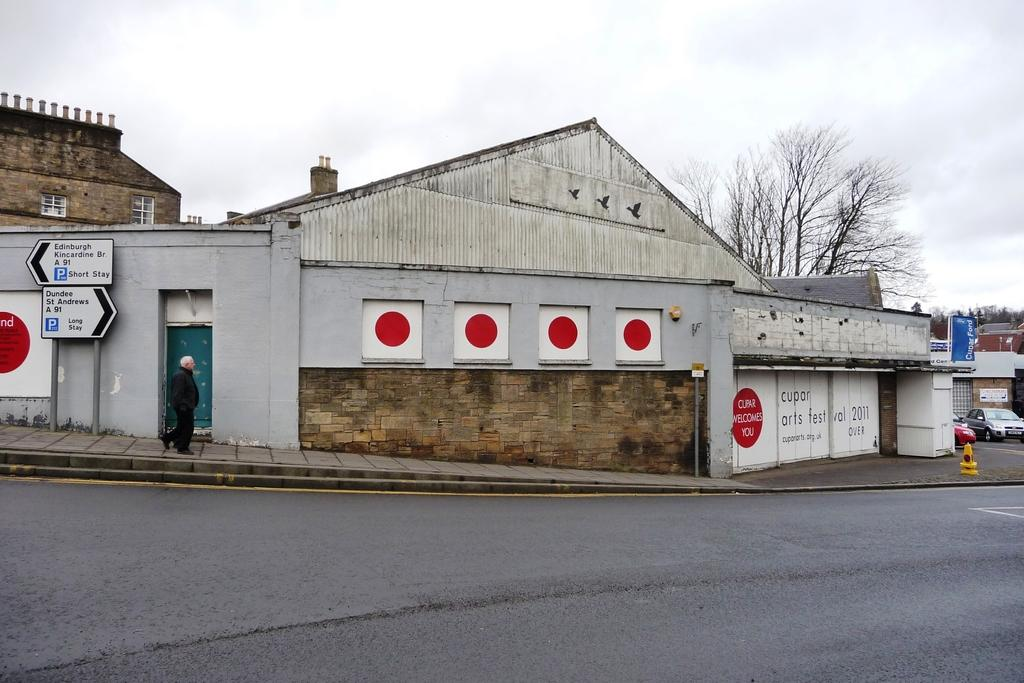What can be seen in the background of the image? In the background of the image, there are buildings, trees, and boards with text. What is the person in the image doing? The person in the image is walking. What type of vehicles are present in the image? There are cars in the image. What is the weather like in the image? The sky is cloudy in the image. Can you see a cap on the person walking in the image? There is no mention of a cap in the image, so it cannot be confirmed or denied. Is there a garden visible in the image? There is no mention of a garden in the image, so it cannot be confirmed or denied. 